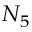<formula> <loc_0><loc_0><loc_500><loc_500>N _ { 5 }</formula> 